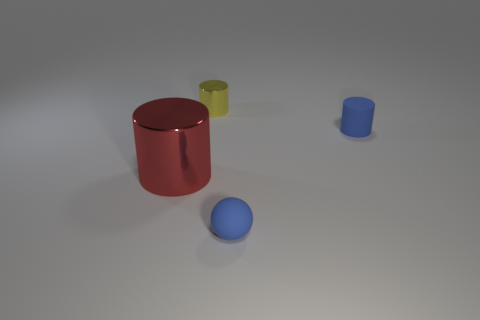Is there any other thing that is the same size as the red metallic cylinder?
Provide a short and direct response. No. Are there any large cylinders of the same color as the tiny shiny object?
Make the answer very short. No. Are there any other things that have the same shape as the small metal object?
Ensure brevity in your answer.  Yes. There is another rubber thing that is the same shape as the big thing; what color is it?
Offer a very short reply. Blue. The thing that is to the left of the yellow metallic cylinder has what shape?
Ensure brevity in your answer.  Cylinder. There is a small blue rubber cylinder; are there any tiny objects in front of it?
Your answer should be compact. Yes. What is the color of the other big cylinder that is made of the same material as the yellow cylinder?
Offer a very short reply. Red. There is a tiny object that is right of the matte ball; does it have the same color as the small cylinder that is on the left side of the small matte cylinder?
Give a very brief answer. No. What number of cylinders are either small objects or tiny shiny things?
Offer a very short reply. 2. Are there the same number of tiny yellow shiny objects that are on the left side of the blue rubber sphere and large red cylinders?
Your answer should be very brief. Yes. 